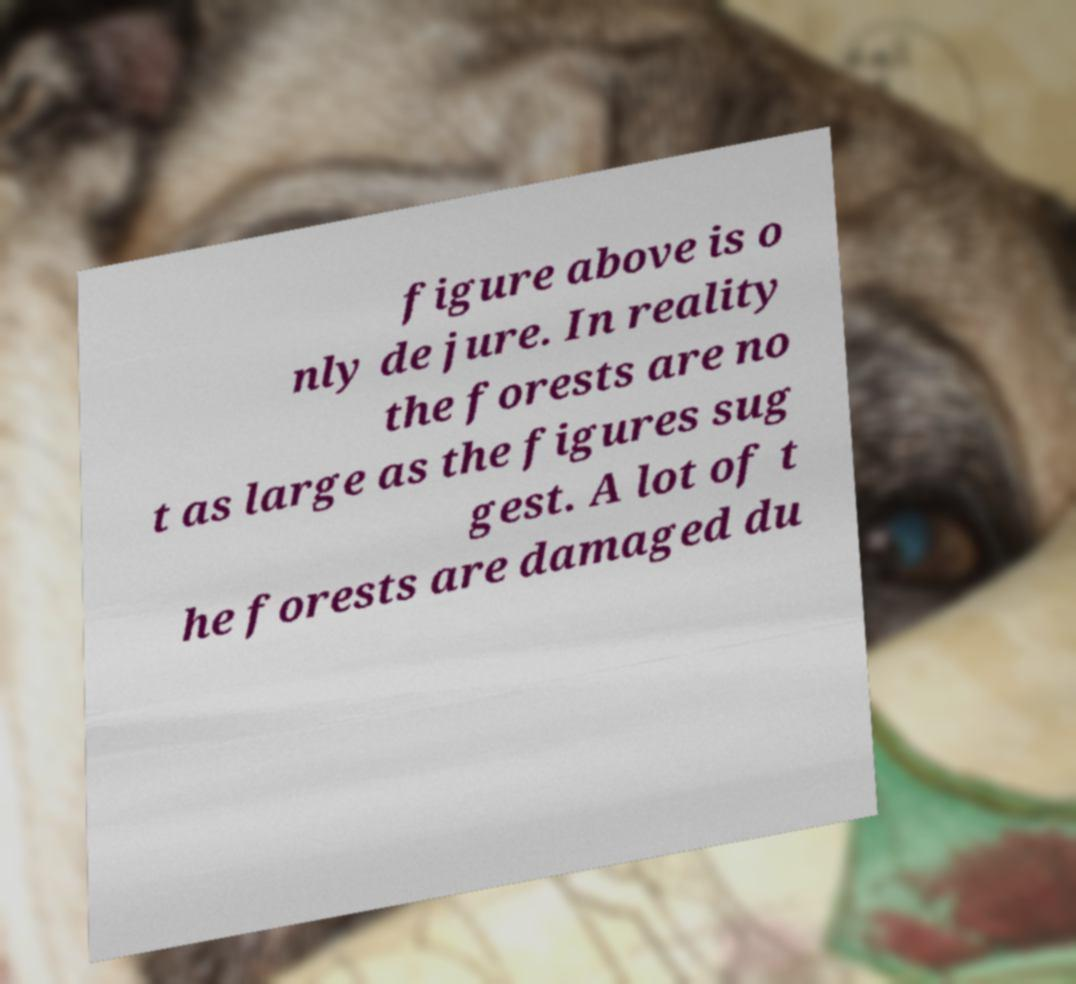I need the written content from this picture converted into text. Can you do that? figure above is o nly de jure. In reality the forests are no t as large as the figures sug gest. A lot of t he forests are damaged du 